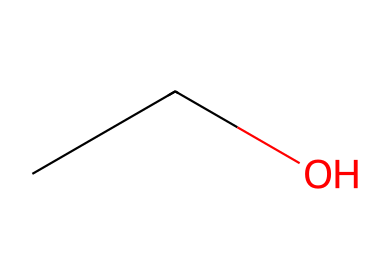How many carbon atoms are present in ethanol? The SMILES representation "CCO" indicates that there are two carbon atoms (C) connected in a linear fashion. The "CC" portion denotes that there are two adjacent carbon atoms in the molecular structure.
Answer: 2 What is the functional group present in ethanol? In the structure "CCO," the "O" indicates the presence of a hydroxyl (-OH) group, which characterizes ethanol as an alcohol due to this functional group.
Answer: hydroxyl How many hydrogen atoms are there in ethanol? Analyzing the structure "CCO," each carbon (2 carbons) is bonded to a certain number of hydrogen atoms to satisfy carbon’s tetravalency. The 2 carbon atoms together allow for a total of 6 hydrogen atoms in this case.
Answer: 6 What type of compound is ethanol classified as? Ethanol's structure represented by "CCO" indicates that it is an alcohol, specifically a type of aliphatic compound due to its linear carbon chain and hydroxyl functional group.
Answer: alcohol Is ethanol soluble in water? Ethanol contains a hydroxyl group (-OH), which promotes hydrogen bonding with water molecules, indicating that it is soluble in water.
Answer: soluble What is the molecular formula of ethanol? From the SMILES representation "CCO," we deduce the molecular formula by counting the atoms: 2 carbons (C2), 6 hydrogens (H6), and 1 oxygen (O), which results in the formula C2H6O.
Answer: C2H6O 